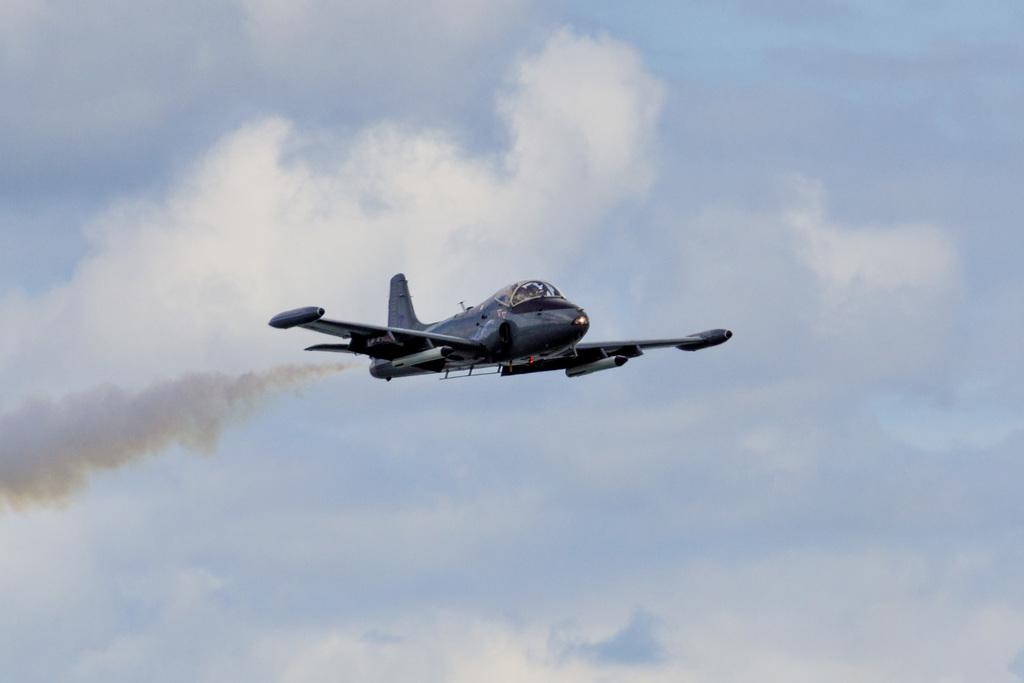What is the main subject of the image? The main subject of the image is an aeroplane. What is the aeroplane doing in the image? The aeroplane is flying in the sky. What type of hill can be seen in the background of the image? There is no hill present in the image; it features an aeroplane flying in the sky. What feeling does the aeroplane evoke in the image? The image does not convey a specific feeling or emotion; it simply shows an aeroplane flying in the sky. 